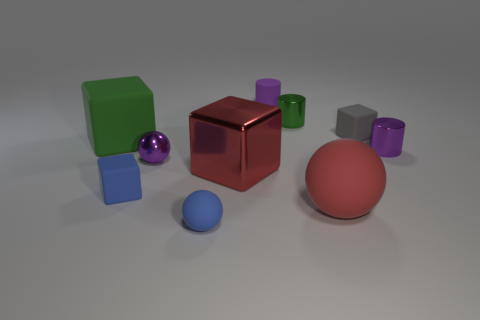Subtract all blue balls. How many purple cylinders are left? 2 Subtract 2 cubes. How many cubes are left? 2 Subtract all small green metallic cylinders. How many cylinders are left? 2 Subtract all green blocks. How many blocks are left? 3 Subtract all cubes. How many objects are left? 6 Subtract all purple blocks. Subtract all red cylinders. How many blocks are left? 4 Subtract all spheres. Subtract all purple spheres. How many objects are left? 6 Add 2 small purple shiny spheres. How many small purple shiny spheres are left? 3 Add 5 small blocks. How many small blocks exist? 7 Subtract 1 blue blocks. How many objects are left? 9 